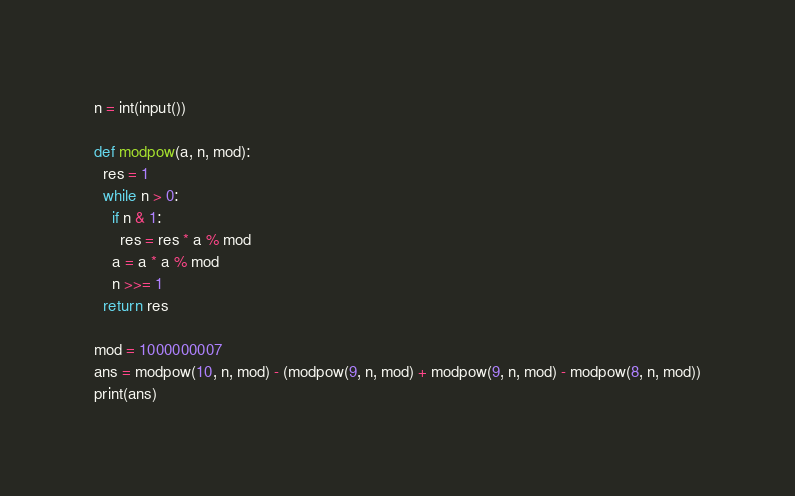Convert code to text. <code><loc_0><loc_0><loc_500><loc_500><_Python_>n = int(input())

def modpow(a, n, mod):
  res = 1
  while n > 0:
    if n & 1:
      res = res * a % mod
    a = a * a % mod
    n >>= 1
  return res

mod = 1000000007
ans = modpow(10, n, mod) - (modpow(9, n, mod) + modpow(9, n, mod) - modpow(8, n, mod))
print(ans)</code> 